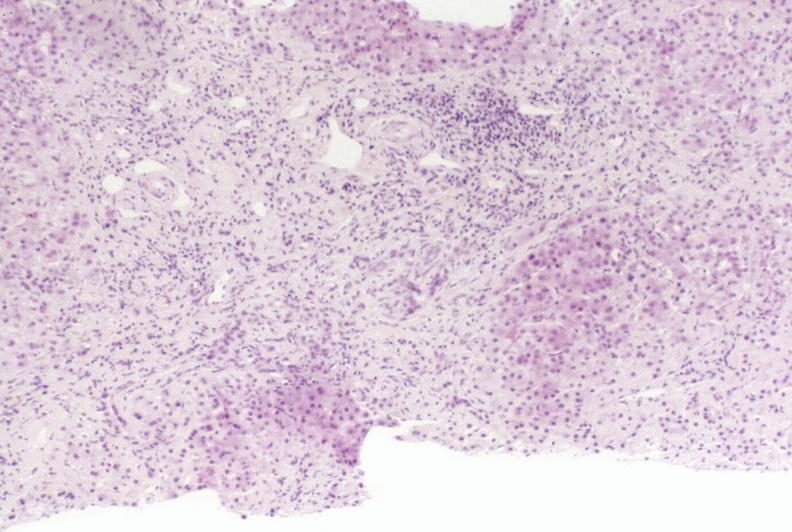does purulent sinusitis show primary sclerosing cholangitis?
Answer the question using a single word or phrase. No 